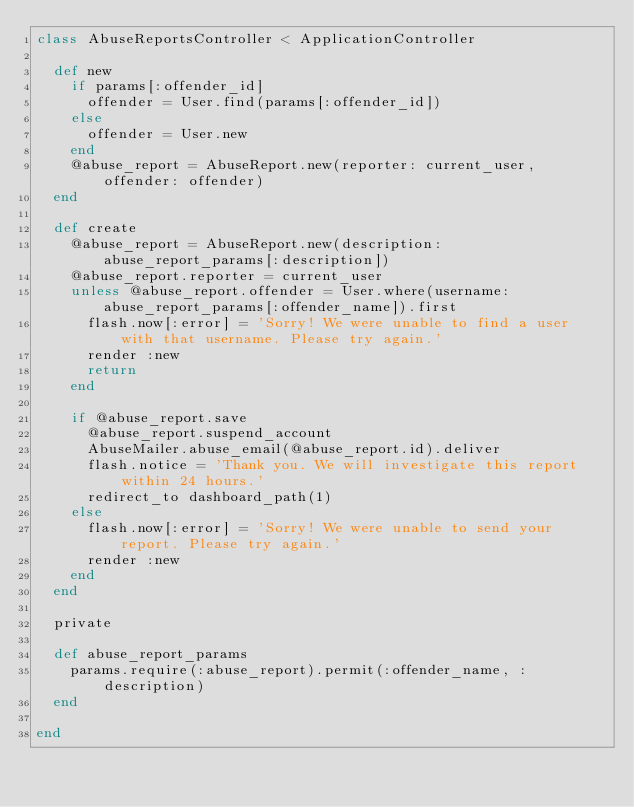Convert code to text. <code><loc_0><loc_0><loc_500><loc_500><_Ruby_>class AbuseReportsController < ApplicationController

  def new
    if params[:offender_id]
      offender = User.find(params[:offender_id])
    else
      offender = User.new
    end
    @abuse_report = AbuseReport.new(reporter: current_user, offender: offender)
  end

  def create
    @abuse_report = AbuseReport.new(description: abuse_report_params[:description])
    @abuse_report.reporter = current_user
    unless @abuse_report.offender = User.where(username: abuse_report_params[:offender_name]).first
      flash.now[:error] = 'Sorry! We were unable to find a user with that username. Please try again.'
      render :new
      return
    end

    if @abuse_report.save
      @abuse_report.suspend_account
      AbuseMailer.abuse_email(@abuse_report.id).deliver
      flash.notice = 'Thank you. We will investigate this report within 24 hours.'
      redirect_to dashboard_path(1)
    else
      flash.now[:error] = 'Sorry! We were unable to send your report. Please try again.'
      render :new
    end
  end

  private

  def abuse_report_params
    params.require(:abuse_report).permit(:offender_name, :description)
  end

end</code> 